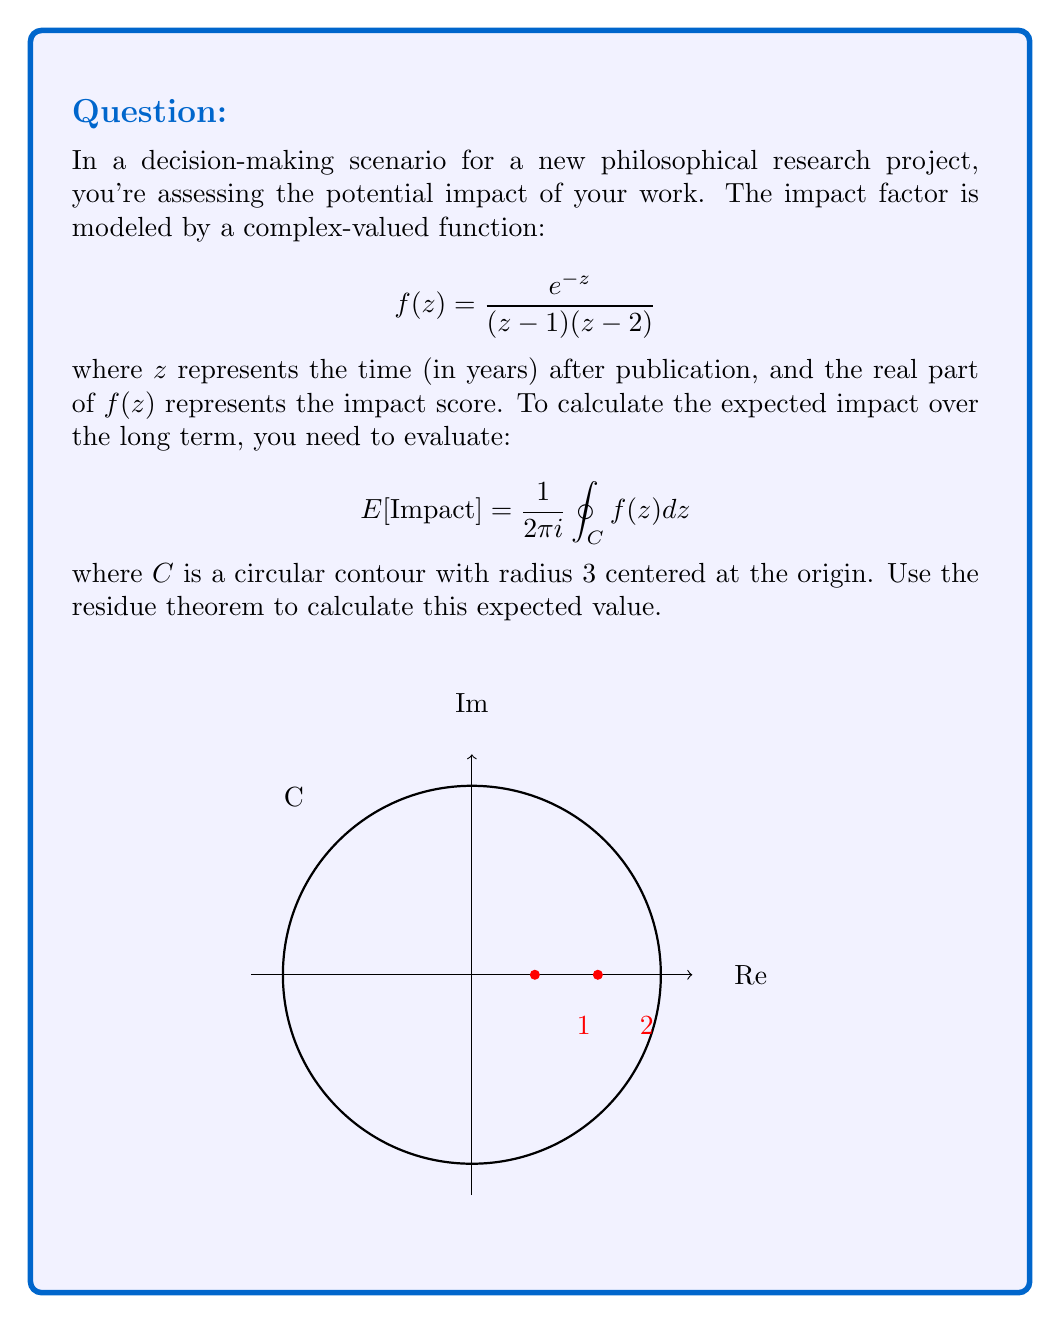Show me your answer to this math problem. Let's approach this step-by-step using the residue theorem:

1) The residue theorem states that for a meromorphic function $f(z)$:

   $$\oint_C f(z) dz = 2\pi i \sum_{k=1}^n \text{Res}(f, a_k)$$

   where $a_k$ are the poles of $f(z)$ inside the contour $C$.

2) Our function has two poles: $z=1$ and $z=2$, both inside the contour.

3) To find the residues, we'll use the formula for simple poles:

   $$\text{Res}(f, a) = \lim_{z \to a} (z-a)f(z)$$

4) For $z=1$:
   $$\text{Res}(f, 1) = \lim_{z \to 1} (z-1)\frac{e^{-z}}{(z-1)(z-2)} = \lim_{z \to 1} \frac{e^{-z}}{z-2} = -\frac{e^{-1}}{1} = -e^{-1}$$

5) For $z=2$:
   $$\text{Res}(f, 2) = \lim_{z \to 2} (z-2)\frac{e^{-z}}{(z-1)(z-2)} = \lim_{z \to 2} \frac{e^{-z}}{z-1} = \frac{e^{-2}}{1} = e^{-2}$$

6) Applying the residue theorem:

   $$\oint_C f(z) dz = 2\pi i (\text{Res}(f, 1) + \text{Res}(f, 2)) = 2\pi i (-e^{-1} + e^{-2})$$

7) Therefore, the expected impact is:

   $$E[Impact] = \frac{1}{2\pi i} \oint_C f(z) dz = -e^{-1} + e^{-2}$$
Answer: $-e^{-1} + e^{-2}$ 